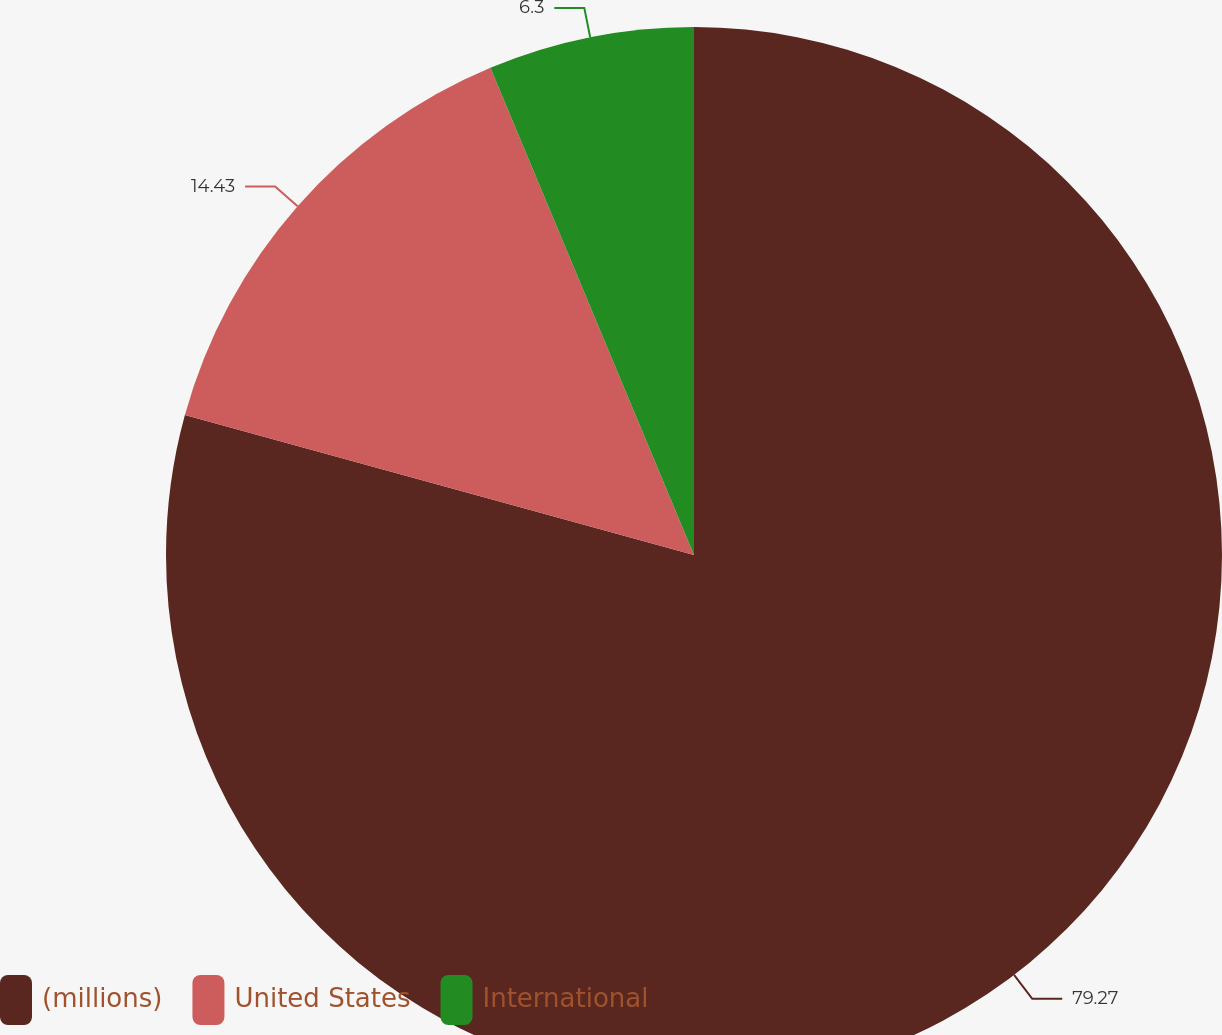Convert chart to OTSL. <chart><loc_0><loc_0><loc_500><loc_500><pie_chart><fcel>(millions)<fcel>United States<fcel>International<nl><fcel>79.27%<fcel>14.43%<fcel>6.3%<nl></chart> 